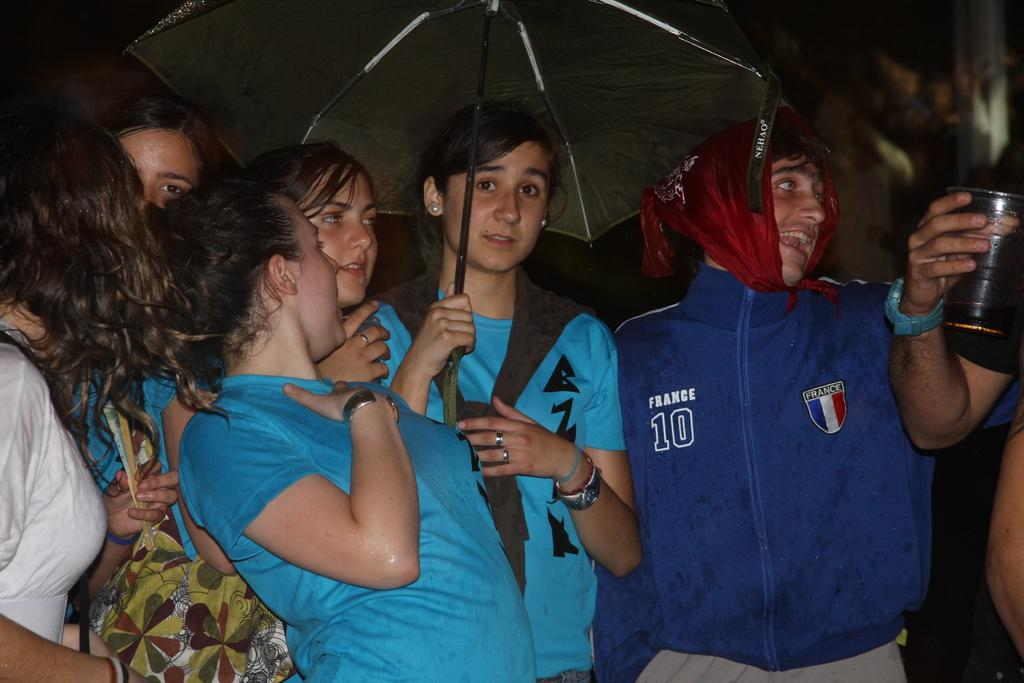What is the main subject of the image? The main subject of the image is people standing near a big wall. What are the people holding in the image? Some people are holding objects in the image. Can you describe the woman holding an umbrella? Yes, one woman is holding an umbrella in the image. What type of flowers can be seen growing on the wall in the image? There are no flowers visible on the wall in the image. Can you describe the yak that is standing next to the woman with the umbrella? There is no yak present in the image; it only features people standing near a big wall. 